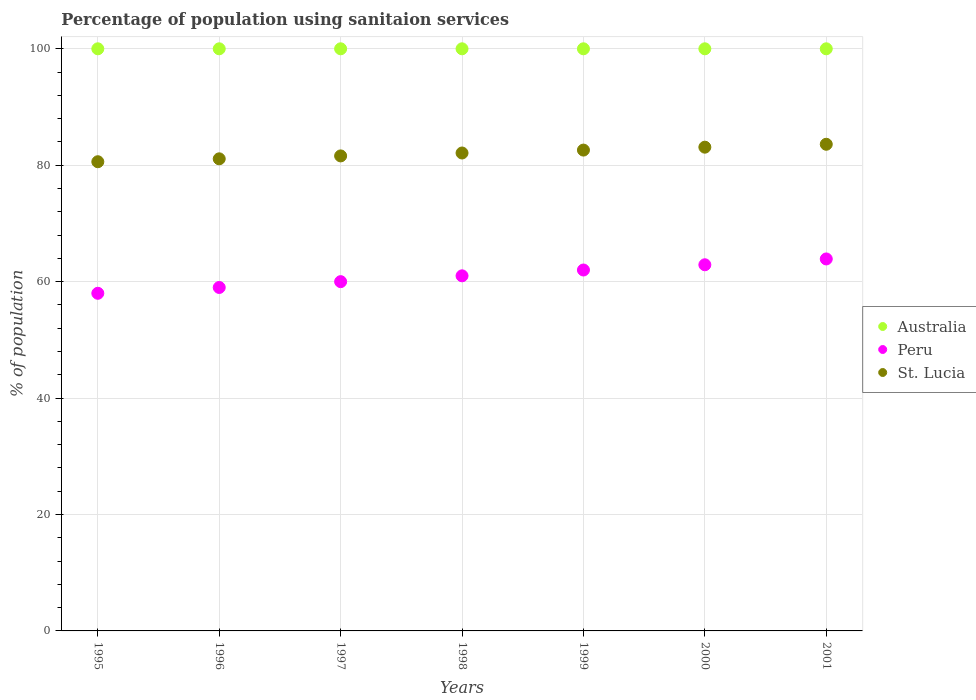Across all years, what is the maximum percentage of population using sanitaion services in Peru?
Your response must be concise. 63.9. Across all years, what is the minimum percentage of population using sanitaion services in St. Lucia?
Offer a terse response. 80.6. What is the total percentage of population using sanitaion services in Peru in the graph?
Your answer should be very brief. 426.8. What is the difference between the percentage of population using sanitaion services in Australia in 1998 and the percentage of population using sanitaion services in St. Lucia in 1999?
Your answer should be very brief. 17.4. What is the average percentage of population using sanitaion services in St. Lucia per year?
Provide a short and direct response. 82.1. In the year 1997, what is the difference between the percentage of population using sanitaion services in Australia and percentage of population using sanitaion services in St. Lucia?
Keep it short and to the point. 18.4. What is the ratio of the percentage of population using sanitaion services in Australia in 1996 to that in 2000?
Your answer should be compact. 1. What is the difference between the highest and the second highest percentage of population using sanitaion services in St. Lucia?
Ensure brevity in your answer.  0.5. What is the difference between the highest and the lowest percentage of population using sanitaion services in Australia?
Keep it short and to the point. 0. In how many years, is the percentage of population using sanitaion services in Peru greater than the average percentage of population using sanitaion services in Peru taken over all years?
Your response must be concise. 4. Is it the case that in every year, the sum of the percentage of population using sanitaion services in Australia and percentage of population using sanitaion services in Peru  is greater than the percentage of population using sanitaion services in St. Lucia?
Make the answer very short. Yes. Does the percentage of population using sanitaion services in Peru monotonically increase over the years?
Your response must be concise. Yes. Is the percentage of population using sanitaion services in Australia strictly greater than the percentage of population using sanitaion services in St. Lucia over the years?
Your answer should be very brief. Yes. How many dotlines are there?
Keep it short and to the point. 3. How many years are there in the graph?
Your response must be concise. 7. What is the difference between two consecutive major ticks on the Y-axis?
Provide a succinct answer. 20. How many legend labels are there?
Give a very brief answer. 3. What is the title of the graph?
Offer a terse response. Percentage of population using sanitaion services. What is the label or title of the X-axis?
Give a very brief answer. Years. What is the label or title of the Y-axis?
Your response must be concise. % of population. What is the % of population of Peru in 1995?
Give a very brief answer. 58. What is the % of population in St. Lucia in 1995?
Your answer should be compact. 80.6. What is the % of population of St. Lucia in 1996?
Provide a succinct answer. 81.1. What is the % of population in Peru in 1997?
Provide a succinct answer. 60. What is the % of population of St. Lucia in 1997?
Offer a terse response. 81.6. What is the % of population of Peru in 1998?
Your answer should be very brief. 61. What is the % of population in St. Lucia in 1998?
Keep it short and to the point. 82.1. What is the % of population in Australia in 1999?
Provide a short and direct response. 100. What is the % of population in St. Lucia in 1999?
Offer a terse response. 82.6. What is the % of population in Peru in 2000?
Make the answer very short. 62.9. What is the % of population in St. Lucia in 2000?
Keep it short and to the point. 83.1. What is the % of population of Peru in 2001?
Ensure brevity in your answer.  63.9. What is the % of population in St. Lucia in 2001?
Keep it short and to the point. 83.6. Across all years, what is the maximum % of population in Peru?
Provide a short and direct response. 63.9. Across all years, what is the maximum % of population of St. Lucia?
Provide a succinct answer. 83.6. Across all years, what is the minimum % of population of St. Lucia?
Provide a short and direct response. 80.6. What is the total % of population in Australia in the graph?
Provide a short and direct response. 700. What is the total % of population in Peru in the graph?
Ensure brevity in your answer.  426.8. What is the total % of population of St. Lucia in the graph?
Ensure brevity in your answer.  574.7. What is the difference between the % of population of Peru in 1995 and that in 1996?
Your response must be concise. -1. What is the difference between the % of population of Peru in 1995 and that in 1997?
Provide a short and direct response. -2. What is the difference between the % of population of St. Lucia in 1995 and that in 1997?
Offer a very short reply. -1. What is the difference between the % of population in Peru in 1995 and that in 1998?
Provide a short and direct response. -3. What is the difference between the % of population in St. Lucia in 1995 and that in 1998?
Your answer should be compact. -1.5. What is the difference between the % of population in Peru in 1995 and that in 1999?
Provide a short and direct response. -4. What is the difference between the % of population of St. Lucia in 1995 and that in 1999?
Your answer should be very brief. -2. What is the difference between the % of population in St. Lucia in 1995 and that in 2000?
Provide a succinct answer. -2.5. What is the difference between the % of population in Australia in 1996 and that in 1998?
Your answer should be very brief. 0. What is the difference between the % of population in Peru in 1996 and that in 1999?
Provide a short and direct response. -3. What is the difference between the % of population of Peru in 1996 and that in 2000?
Ensure brevity in your answer.  -3.9. What is the difference between the % of population of Peru in 1996 and that in 2001?
Offer a terse response. -4.9. What is the difference between the % of population in Australia in 1997 and that in 1998?
Provide a short and direct response. 0. What is the difference between the % of population of Peru in 1997 and that in 1998?
Your answer should be very brief. -1. What is the difference between the % of population of St. Lucia in 1997 and that in 1998?
Offer a very short reply. -0.5. What is the difference between the % of population of Australia in 1997 and that in 1999?
Offer a very short reply. 0. What is the difference between the % of population of Australia in 1997 and that in 2001?
Give a very brief answer. 0. What is the difference between the % of population in Peru in 1997 and that in 2001?
Give a very brief answer. -3.9. What is the difference between the % of population in St. Lucia in 1997 and that in 2001?
Keep it short and to the point. -2. What is the difference between the % of population in Australia in 1998 and that in 1999?
Offer a terse response. 0. What is the difference between the % of population in St. Lucia in 1998 and that in 1999?
Make the answer very short. -0.5. What is the difference between the % of population in Australia in 1998 and that in 2000?
Ensure brevity in your answer.  0. What is the difference between the % of population of Peru in 1998 and that in 2000?
Keep it short and to the point. -1.9. What is the difference between the % of population of Australia in 1998 and that in 2001?
Make the answer very short. 0. What is the difference between the % of population of Peru in 1998 and that in 2001?
Offer a terse response. -2.9. What is the difference between the % of population in Australia in 1999 and that in 2000?
Make the answer very short. 0. What is the difference between the % of population of Peru in 1999 and that in 2000?
Provide a succinct answer. -0.9. What is the difference between the % of population of Australia in 1999 and that in 2001?
Ensure brevity in your answer.  0. What is the difference between the % of population in Peru in 1999 and that in 2001?
Your answer should be very brief. -1.9. What is the difference between the % of population in St. Lucia in 1999 and that in 2001?
Your answer should be very brief. -1. What is the difference between the % of population of St. Lucia in 2000 and that in 2001?
Give a very brief answer. -0.5. What is the difference between the % of population in Australia in 1995 and the % of population in St. Lucia in 1996?
Make the answer very short. 18.9. What is the difference between the % of population in Peru in 1995 and the % of population in St. Lucia in 1996?
Your answer should be very brief. -23.1. What is the difference between the % of population in Australia in 1995 and the % of population in Peru in 1997?
Offer a terse response. 40. What is the difference between the % of population of Australia in 1995 and the % of population of St. Lucia in 1997?
Make the answer very short. 18.4. What is the difference between the % of population of Peru in 1995 and the % of population of St. Lucia in 1997?
Make the answer very short. -23.6. What is the difference between the % of population in Peru in 1995 and the % of population in St. Lucia in 1998?
Provide a short and direct response. -24.1. What is the difference between the % of population in Australia in 1995 and the % of population in St. Lucia in 1999?
Give a very brief answer. 17.4. What is the difference between the % of population of Peru in 1995 and the % of population of St. Lucia in 1999?
Give a very brief answer. -24.6. What is the difference between the % of population in Australia in 1995 and the % of population in Peru in 2000?
Give a very brief answer. 37.1. What is the difference between the % of population of Australia in 1995 and the % of population of St. Lucia in 2000?
Your answer should be compact. 16.9. What is the difference between the % of population in Peru in 1995 and the % of population in St. Lucia in 2000?
Your response must be concise. -25.1. What is the difference between the % of population in Australia in 1995 and the % of population in Peru in 2001?
Offer a very short reply. 36.1. What is the difference between the % of population of Peru in 1995 and the % of population of St. Lucia in 2001?
Your answer should be compact. -25.6. What is the difference between the % of population in Peru in 1996 and the % of population in St. Lucia in 1997?
Ensure brevity in your answer.  -22.6. What is the difference between the % of population in Australia in 1996 and the % of population in Peru in 1998?
Your response must be concise. 39. What is the difference between the % of population of Australia in 1996 and the % of population of St. Lucia in 1998?
Ensure brevity in your answer.  17.9. What is the difference between the % of population in Peru in 1996 and the % of population in St. Lucia in 1998?
Your response must be concise. -23.1. What is the difference between the % of population in Australia in 1996 and the % of population in St. Lucia in 1999?
Your answer should be compact. 17.4. What is the difference between the % of population of Peru in 1996 and the % of population of St. Lucia in 1999?
Your response must be concise. -23.6. What is the difference between the % of population in Australia in 1996 and the % of population in Peru in 2000?
Your answer should be compact. 37.1. What is the difference between the % of population in Australia in 1996 and the % of population in St. Lucia in 2000?
Make the answer very short. 16.9. What is the difference between the % of population in Peru in 1996 and the % of population in St. Lucia in 2000?
Ensure brevity in your answer.  -24.1. What is the difference between the % of population in Australia in 1996 and the % of population in Peru in 2001?
Keep it short and to the point. 36.1. What is the difference between the % of population in Peru in 1996 and the % of population in St. Lucia in 2001?
Provide a short and direct response. -24.6. What is the difference between the % of population of Peru in 1997 and the % of population of St. Lucia in 1998?
Keep it short and to the point. -22.1. What is the difference between the % of population of Australia in 1997 and the % of population of Peru in 1999?
Provide a succinct answer. 38. What is the difference between the % of population in Australia in 1997 and the % of population in St. Lucia in 1999?
Provide a succinct answer. 17.4. What is the difference between the % of population in Peru in 1997 and the % of population in St. Lucia in 1999?
Offer a very short reply. -22.6. What is the difference between the % of population of Australia in 1997 and the % of population of Peru in 2000?
Provide a succinct answer. 37.1. What is the difference between the % of population in Peru in 1997 and the % of population in St. Lucia in 2000?
Your answer should be very brief. -23.1. What is the difference between the % of population in Australia in 1997 and the % of population in Peru in 2001?
Give a very brief answer. 36.1. What is the difference between the % of population of Australia in 1997 and the % of population of St. Lucia in 2001?
Provide a short and direct response. 16.4. What is the difference between the % of population of Peru in 1997 and the % of population of St. Lucia in 2001?
Give a very brief answer. -23.6. What is the difference between the % of population of Peru in 1998 and the % of population of St. Lucia in 1999?
Offer a terse response. -21.6. What is the difference between the % of population of Australia in 1998 and the % of population of Peru in 2000?
Make the answer very short. 37.1. What is the difference between the % of population in Australia in 1998 and the % of population in St. Lucia in 2000?
Offer a terse response. 16.9. What is the difference between the % of population in Peru in 1998 and the % of population in St. Lucia in 2000?
Ensure brevity in your answer.  -22.1. What is the difference between the % of population of Australia in 1998 and the % of population of Peru in 2001?
Provide a succinct answer. 36.1. What is the difference between the % of population in Australia in 1998 and the % of population in St. Lucia in 2001?
Ensure brevity in your answer.  16.4. What is the difference between the % of population in Peru in 1998 and the % of population in St. Lucia in 2001?
Offer a very short reply. -22.6. What is the difference between the % of population in Australia in 1999 and the % of population in Peru in 2000?
Offer a very short reply. 37.1. What is the difference between the % of population in Australia in 1999 and the % of population in St. Lucia in 2000?
Your response must be concise. 16.9. What is the difference between the % of population of Peru in 1999 and the % of population of St. Lucia in 2000?
Give a very brief answer. -21.1. What is the difference between the % of population of Australia in 1999 and the % of population of Peru in 2001?
Ensure brevity in your answer.  36.1. What is the difference between the % of population in Peru in 1999 and the % of population in St. Lucia in 2001?
Provide a short and direct response. -21.6. What is the difference between the % of population in Australia in 2000 and the % of population in Peru in 2001?
Offer a very short reply. 36.1. What is the difference between the % of population in Peru in 2000 and the % of population in St. Lucia in 2001?
Offer a very short reply. -20.7. What is the average % of population of Australia per year?
Provide a short and direct response. 100. What is the average % of population of Peru per year?
Provide a succinct answer. 60.97. What is the average % of population in St. Lucia per year?
Give a very brief answer. 82.1. In the year 1995, what is the difference between the % of population of Australia and % of population of Peru?
Your response must be concise. 42. In the year 1995, what is the difference between the % of population of Australia and % of population of St. Lucia?
Offer a terse response. 19.4. In the year 1995, what is the difference between the % of population of Peru and % of population of St. Lucia?
Offer a very short reply. -22.6. In the year 1996, what is the difference between the % of population of Australia and % of population of Peru?
Offer a very short reply. 41. In the year 1996, what is the difference between the % of population of Peru and % of population of St. Lucia?
Your answer should be very brief. -22.1. In the year 1997, what is the difference between the % of population in Peru and % of population in St. Lucia?
Your response must be concise. -21.6. In the year 1998, what is the difference between the % of population in Peru and % of population in St. Lucia?
Keep it short and to the point. -21.1. In the year 1999, what is the difference between the % of population of Australia and % of population of Peru?
Ensure brevity in your answer.  38. In the year 1999, what is the difference between the % of population in Peru and % of population in St. Lucia?
Ensure brevity in your answer.  -20.6. In the year 2000, what is the difference between the % of population in Australia and % of population in Peru?
Provide a succinct answer. 37.1. In the year 2000, what is the difference between the % of population of Peru and % of population of St. Lucia?
Provide a short and direct response. -20.2. In the year 2001, what is the difference between the % of population of Australia and % of population of Peru?
Your answer should be very brief. 36.1. In the year 2001, what is the difference between the % of population in Peru and % of population in St. Lucia?
Your response must be concise. -19.7. What is the ratio of the % of population in Australia in 1995 to that in 1996?
Provide a short and direct response. 1. What is the ratio of the % of population in Peru in 1995 to that in 1996?
Offer a terse response. 0.98. What is the ratio of the % of population of Australia in 1995 to that in 1997?
Give a very brief answer. 1. What is the ratio of the % of population in Peru in 1995 to that in 1997?
Ensure brevity in your answer.  0.97. What is the ratio of the % of population in St. Lucia in 1995 to that in 1997?
Ensure brevity in your answer.  0.99. What is the ratio of the % of population of Peru in 1995 to that in 1998?
Give a very brief answer. 0.95. What is the ratio of the % of population of St. Lucia in 1995 to that in 1998?
Give a very brief answer. 0.98. What is the ratio of the % of population of Australia in 1995 to that in 1999?
Keep it short and to the point. 1. What is the ratio of the % of population in Peru in 1995 to that in 1999?
Your response must be concise. 0.94. What is the ratio of the % of population in St. Lucia in 1995 to that in 1999?
Provide a succinct answer. 0.98. What is the ratio of the % of population of Peru in 1995 to that in 2000?
Provide a short and direct response. 0.92. What is the ratio of the % of population of St. Lucia in 1995 to that in 2000?
Offer a terse response. 0.97. What is the ratio of the % of population in Australia in 1995 to that in 2001?
Offer a terse response. 1. What is the ratio of the % of population of Peru in 1995 to that in 2001?
Provide a succinct answer. 0.91. What is the ratio of the % of population in St. Lucia in 1995 to that in 2001?
Give a very brief answer. 0.96. What is the ratio of the % of population in Peru in 1996 to that in 1997?
Make the answer very short. 0.98. What is the ratio of the % of population of Australia in 1996 to that in 1998?
Make the answer very short. 1. What is the ratio of the % of population in Peru in 1996 to that in 1998?
Offer a terse response. 0.97. What is the ratio of the % of population in St. Lucia in 1996 to that in 1998?
Offer a terse response. 0.99. What is the ratio of the % of population in Australia in 1996 to that in 1999?
Provide a succinct answer. 1. What is the ratio of the % of population in Peru in 1996 to that in 1999?
Offer a terse response. 0.95. What is the ratio of the % of population of St. Lucia in 1996 to that in 1999?
Your answer should be very brief. 0.98. What is the ratio of the % of population of Australia in 1996 to that in 2000?
Your response must be concise. 1. What is the ratio of the % of population of Peru in 1996 to that in 2000?
Keep it short and to the point. 0.94. What is the ratio of the % of population of St. Lucia in 1996 to that in 2000?
Ensure brevity in your answer.  0.98. What is the ratio of the % of population in Peru in 1996 to that in 2001?
Offer a very short reply. 0.92. What is the ratio of the % of population of St. Lucia in 1996 to that in 2001?
Ensure brevity in your answer.  0.97. What is the ratio of the % of population in Peru in 1997 to that in 1998?
Offer a very short reply. 0.98. What is the ratio of the % of population in St. Lucia in 1997 to that in 1998?
Give a very brief answer. 0.99. What is the ratio of the % of population in St. Lucia in 1997 to that in 1999?
Keep it short and to the point. 0.99. What is the ratio of the % of population in Peru in 1997 to that in 2000?
Provide a succinct answer. 0.95. What is the ratio of the % of population in St. Lucia in 1997 to that in 2000?
Your answer should be very brief. 0.98. What is the ratio of the % of population in Peru in 1997 to that in 2001?
Offer a very short reply. 0.94. What is the ratio of the % of population in St. Lucia in 1997 to that in 2001?
Your answer should be compact. 0.98. What is the ratio of the % of population in Australia in 1998 to that in 1999?
Offer a terse response. 1. What is the ratio of the % of population of Peru in 1998 to that in 1999?
Offer a terse response. 0.98. What is the ratio of the % of population in Australia in 1998 to that in 2000?
Your response must be concise. 1. What is the ratio of the % of population in Peru in 1998 to that in 2000?
Your answer should be compact. 0.97. What is the ratio of the % of population in Australia in 1998 to that in 2001?
Provide a succinct answer. 1. What is the ratio of the % of population of Peru in 1998 to that in 2001?
Make the answer very short. 0.95. What is the ratio of the % of population of St. Lucia in 1998 to that in 2001?
Offer a very short reply. 0.98. What is the ratio of the % of population of Australia in 1999 to that in 2000?
Provide a succinct answer. 1. What is the ratio of the % of population of Peru in 1999 to that in 2000?
Provide a short and direct response. 0.99. What is the ratio of the % of population of St. Lucia in 1999 to that in 2000?
Your answer should be compact. 0.99. What is the ratio of the % of population in Australia in 1999 to that in 2001?
Provide a succinct answer. 1. What is the ratio of the % of population in Peru in 1999 to that in 2001?
Provide a short and direct response. 0.97. What is the ratio of the % of population in Peru in 2000 to that in 2001?
Provide a short and direct response. 0.98. What is the ratio of the % of population in St. Lucia in 2000 to that in 2001?
Offer a very short reply. 0.99. What is the difference between the highest and the second highest % of population of Australia?
Offer a very short reply. 0. What is the difference between the highest and the lowest % of population in Australia?
Offer a very short reply. 0. What is the difference between the highest and the lowest % of population in Peru?
Provide a succinct answer. 5.9. 